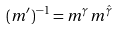Convert formula to latex. <formula><loc_0><loc_0><loc_500><loc_500>( m ^ { \prime } ) ^ { - 1 } = m ^ { \gamma _ { \sl } } m ^ { \hat { \gamma } _ { \sl } }</formula> 